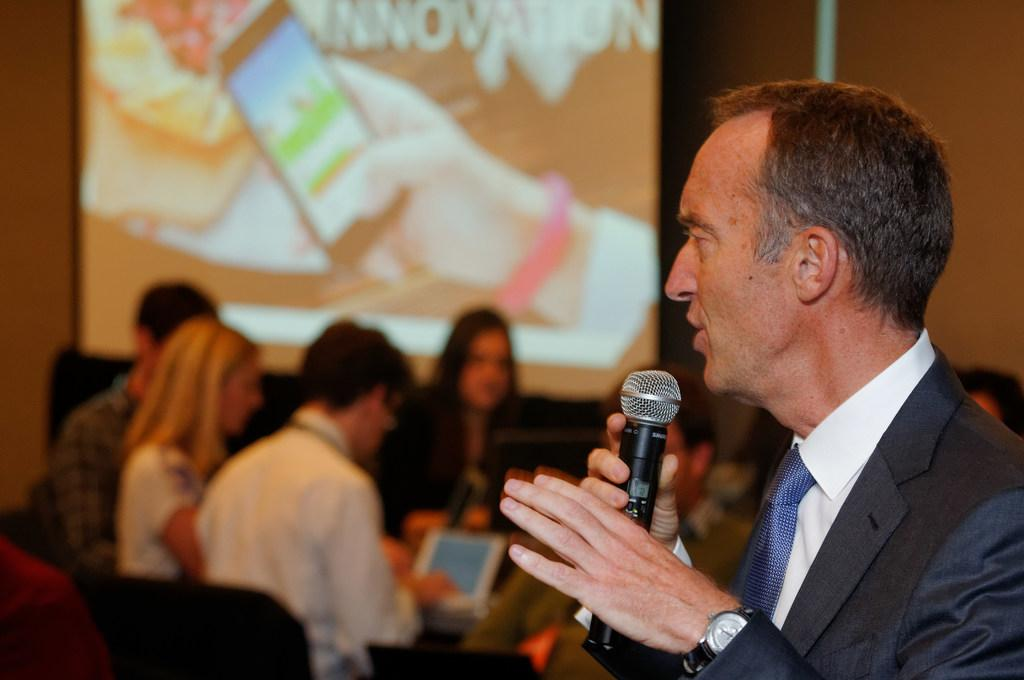What is the person in the image wearing? There is a person wearing a suit in the image. What is the person doing in front of the microphone? The person is speaking in front of a microphone. Can you describe the audience in the image? There are people sitting behind the speaker. What type of road can be seen in the image? There is no road present in the image. Is there a list of cabbage prices visible in the image? There is no list of cabbage prices present in the image. 